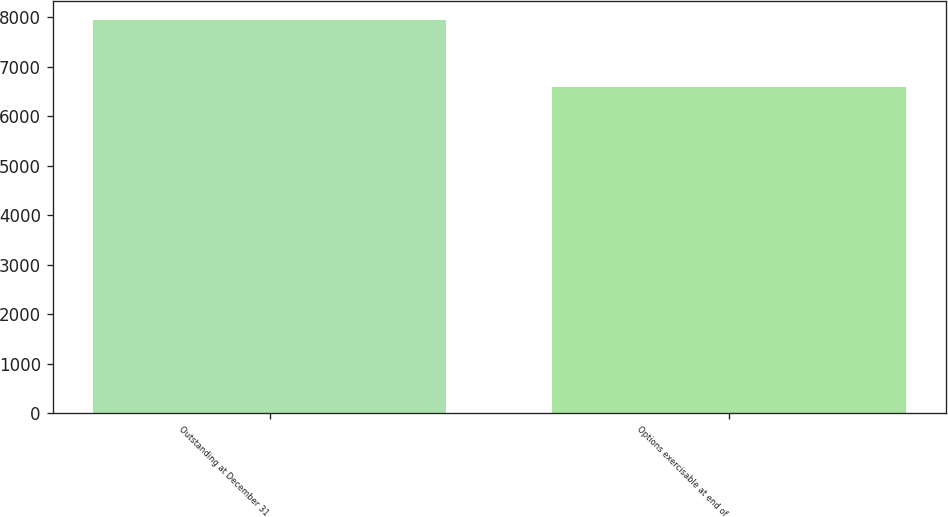Convert chart. <chart><loc_0><loc_0><loc_500><loc_500><bar_chart><fcel>Outstanding at December 31<fcel>Options exercisable at end of<nl><fcel>7937<fcel>6594<nl></chart> 